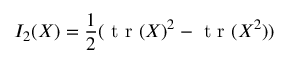Convert formula to latex. <formula><loc_0><loc_0><loc_500><loc_500>I _ { 2 } ( X ) = \frac { 1 } { 2 } ( t r ( X ) ^ { 2 } - t r ( X ^ { 2 } ) )</formula> 